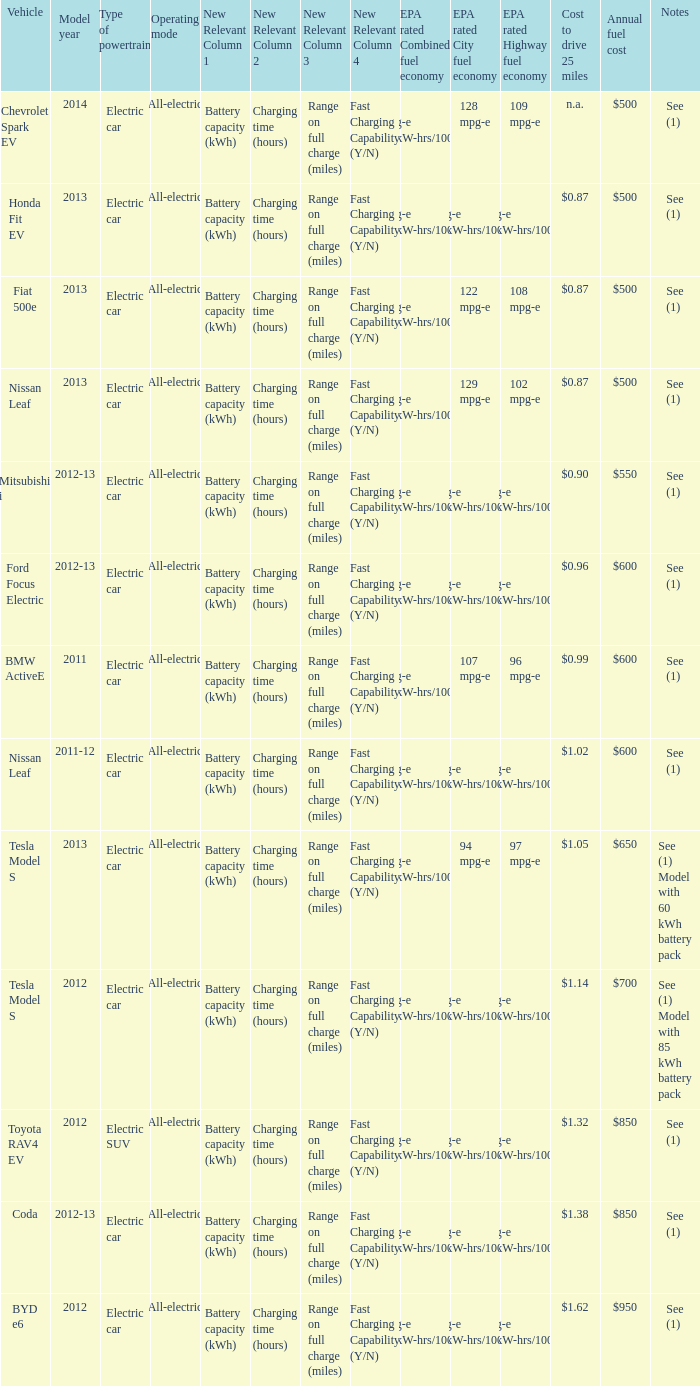What vehicle has an epa highway fuel economy of 109 mpg-e? Chevrolet Spark EV. 